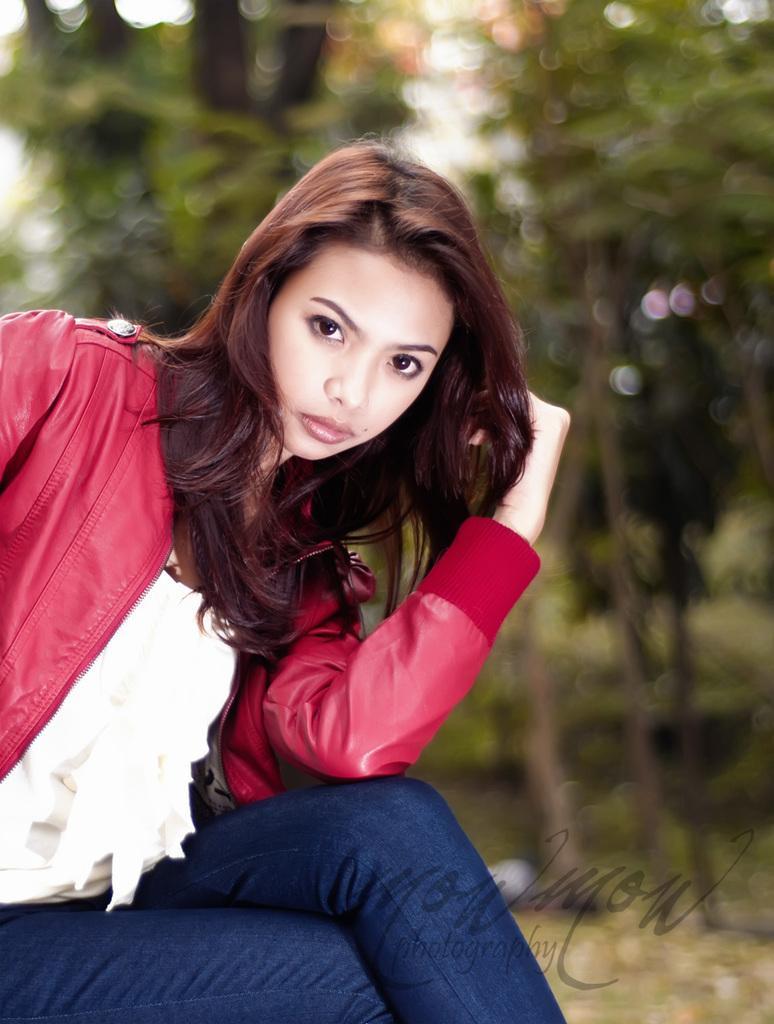How would you summarize this image in a sentence or two? In this image I can see on the left side there is a girl, she is wearing a coat, trouser. At the bottom there is the watermark, in the background it looks like there are trees. 